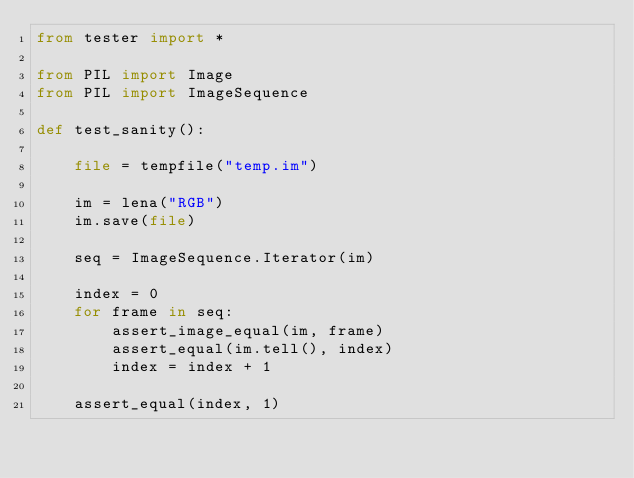<code> <loc_0><loc_0><loc_500><loc_500><_Python_>from tester import *

from PIL import Image
from PIL import ImageSequence

def test_sanity():

    file = tempfile("temp.im")

    im = lena("RGB")
    im.save(file)

    seq = ImageSequence.Iterator(im)

    index = 0
    for frame in seq:
        assert_image_equal(im, frame)
        assert_equal(im.tell(), index)
        index = index + 1

    assert_equal(index, 1)

</code> 